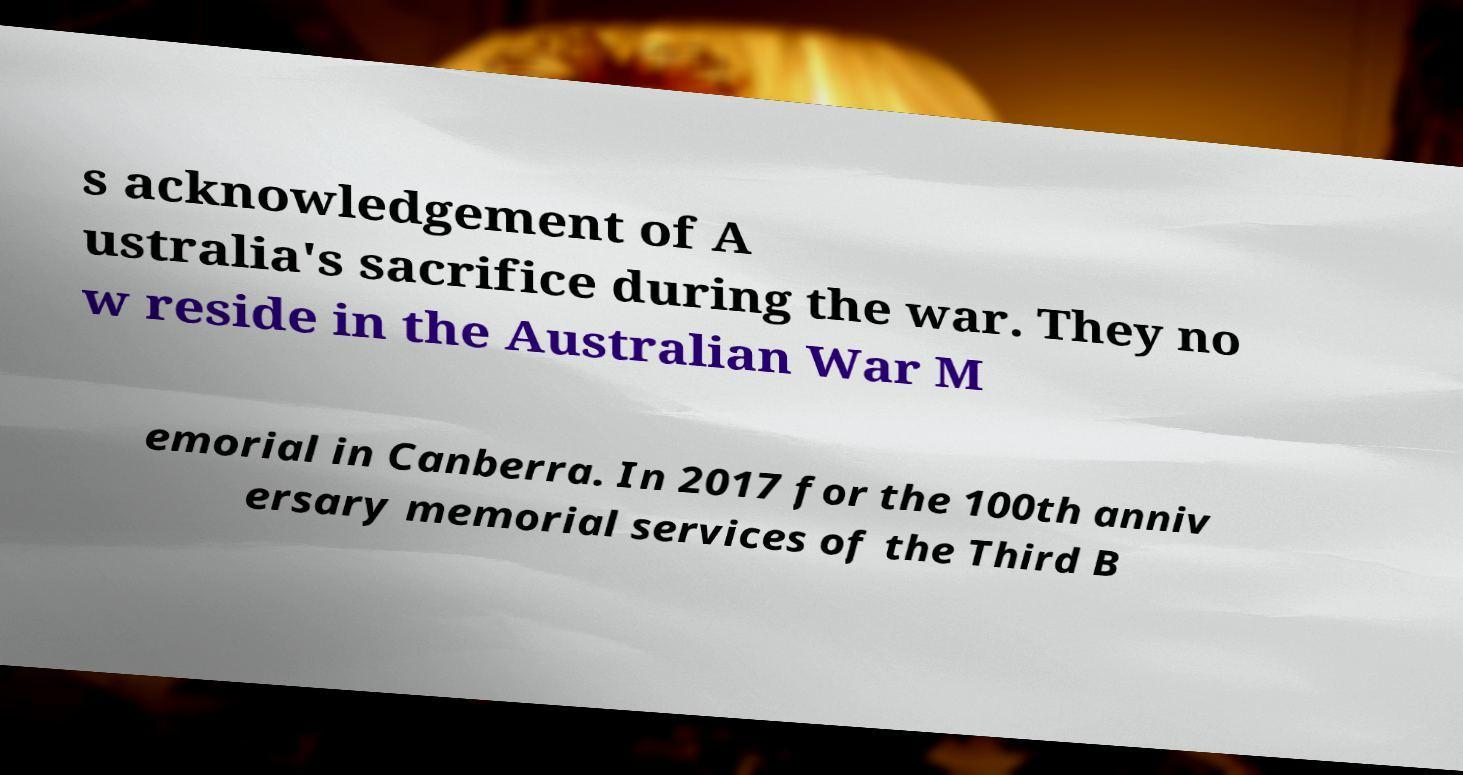Please identify and transcribe the text found in this image. s acknowledgement of A ustralia's sacrifice during the war. They no w reside in the Australian War M emorial in Canberra. In 2017 for the 100th anniv ersary memorial services of the Third B 